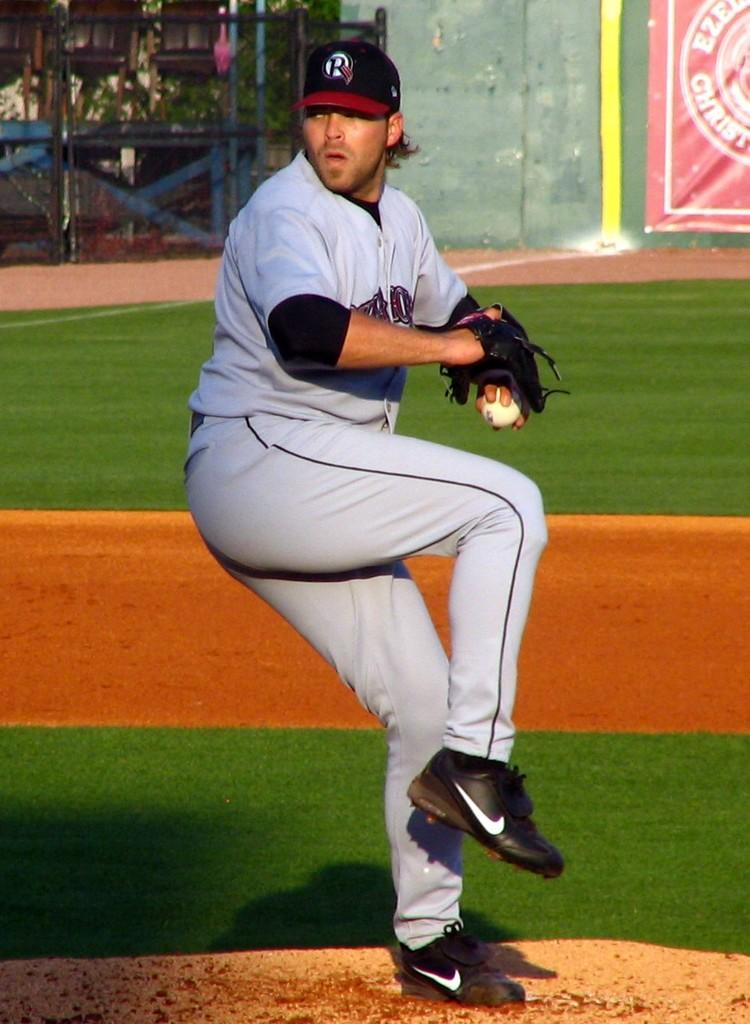<image>
Provide a brief description of the given image. A pitcher is throwing a pitch in front of a red ad that reads Christ. 